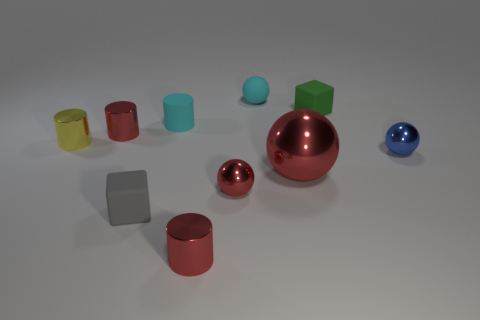Subtract all small rubber cylinders. How many cylinders are left? 3 Subtract all blue cylinders. How many red spheres are left? 2 Subtract all blue balls. How many balls are left? 3 Subtract all blocks. How many objects are left? 8 Add 10 cyan metal cylinders. How many cyan metal cylinders exist? 10 Subtract 1 red balls. How many objects are left? 9 Subtract 2 cubes. How many cubes are left? 0 Subtract all cyan cubes. Subtract all cyan cylinders. How many cubes are left? 2 Subtract all green rubber things. Subtract all tiny yellow things. How many objects are left? 8 Add 6 small green rubber things. How many small green rubber things are left? 7 